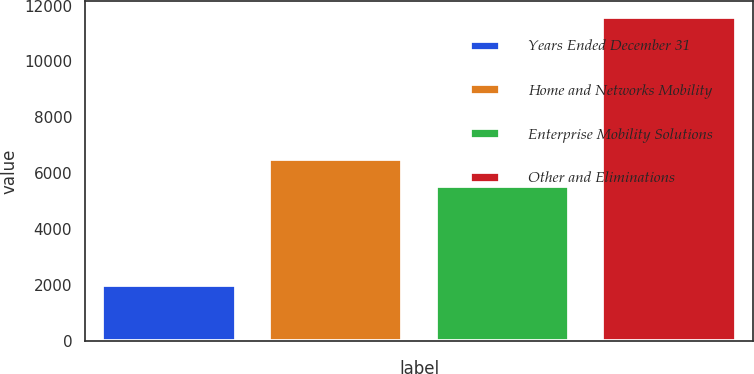<chart> <loc_0><loc_0><loc_500><loc_500><bar_chart><fcel>Years Ended December 31<fcel>Home and Networks Mobility<fcel>Enterprise Mobility Solutions<fcel>Other and Eliminations<nl><fcel>2009<fcel>6517.5<fcel>5559<fcel>11594<nl></chart> 